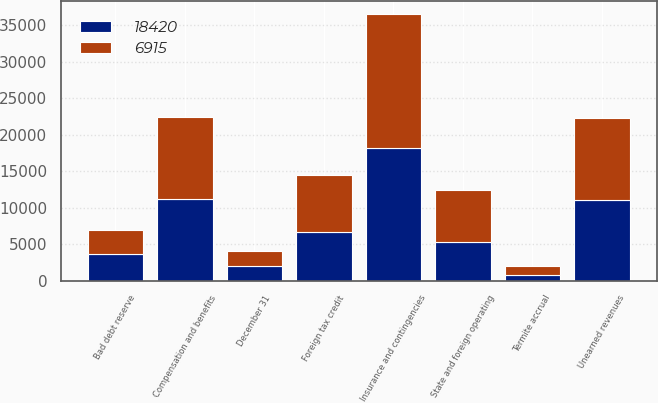Convert chart to OTSL. <chart><loc_0><loc_0><loc_500><loc_500><stacked_bar_chart><ecel><fcel>December 31<fcel>Termite accrual<fcel>Insurance and contingencies<fcel>Unearned revenues<fcel>Compensation and benefits<fcel>State and foreign operating<fcel>Bad debt reserve<fcel>Foreign tax credit<nl><fcel>18420<fcel>2018<fcel>812<fcel>18136<fcel>11091<fcel>11238<fcel>5346<fcel>3687<fcel>6664<nl><fcel>6915<fcel>2017<fcel>1241<fcel>18374<fcel>11152<fcel>11157<fcel>7035<fcel>3203<fcel>7842<nl></chart> 